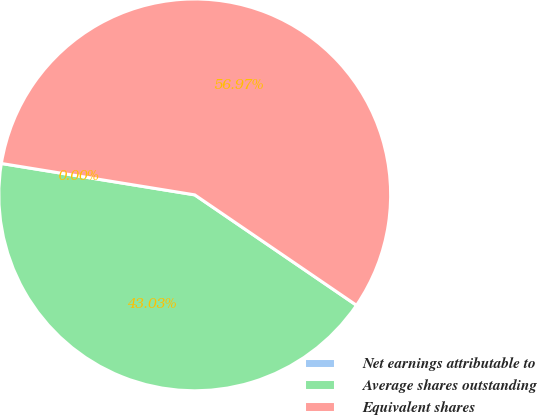<chart> <loc_0><loc_0><loc_500><loc_500><pie_chart><fcel>Net earnings attributable to<fcel>Average shares outstanding<fcel>Equivalent shares<nl><fcel>0.0%<fcel>43.03%<fcel>56.97%<nl></chart> 